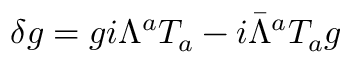Convert formula to latex. <formula><loc_0><loc_0><loc_500><loc_500>\delta g = g i \Lambda ^ { a } T _ { a } - i \bar { \Lambda } ^ { a } T _ { a } g</formula> 